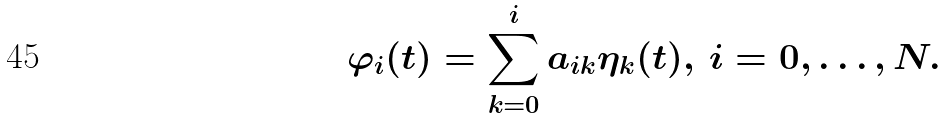Convert formula to latex. <formula><loc_0><loc_0><loc_500><loc_500>\varphi _ { i } ( t ) = \sum _ { k = 0 } ^ { i } a _ { i k } \eta _ { k } ( t ) , \, i = 0 , \dots , N .</formula> 